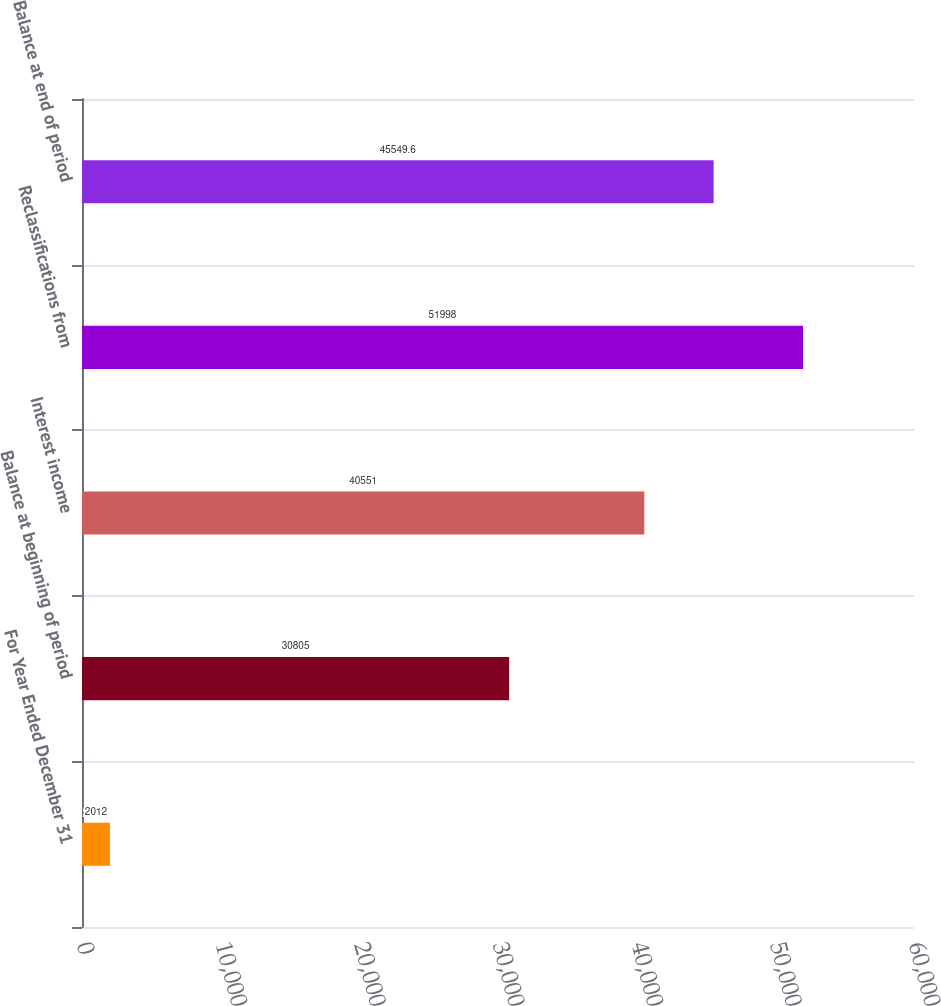Convert chart. <chart><loc_0><loc_0><loc_500><loc_500><bar_chart><fcel>For Year Ended December 31<fcel>Balance at beginning of period<fcel>Interest income<fcel>Reclassifications from<fcel>Balance at end of period<nl><fcel>2012<fcel>30805<fcel>40551<fcel>51998<fcel>45549.6<nl></chart> 